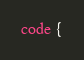<code> <loc_0><loc_0><loc_500><loc_500><_CSS_>code {</code> 